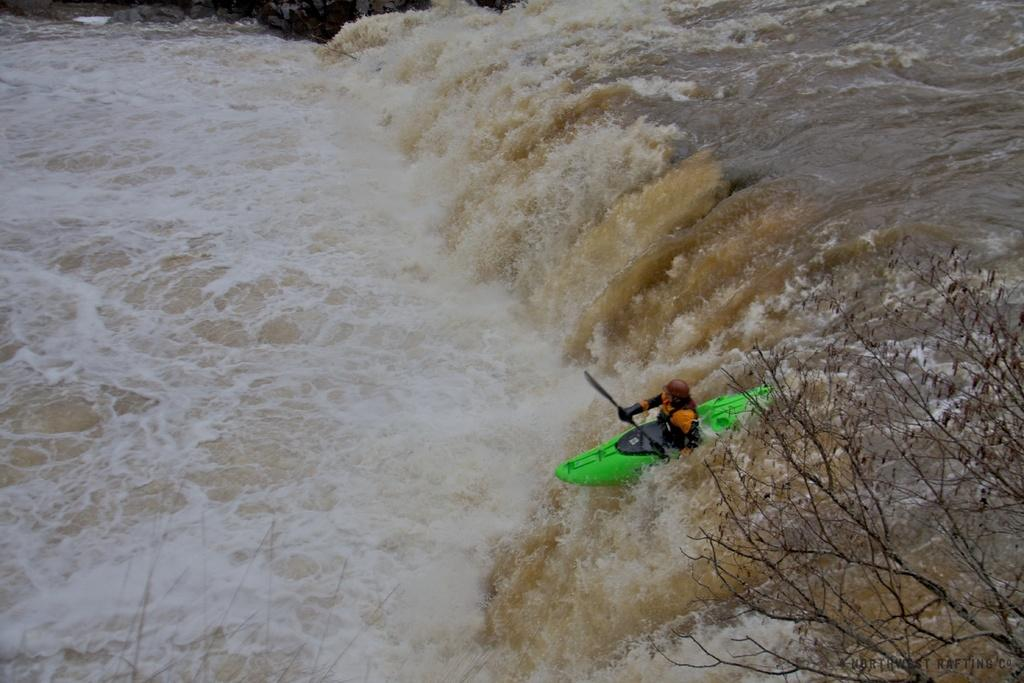What activity is the person in the image engaged in? The person is rafting in the river. Can you describe any other objects or elements in the image? There is a branch of a tree in the bottom right-hand corner of the image. What year is the flag being taught in the image? There is no flag present in the image, so it cannot be taught or have a specific year associated with it. 